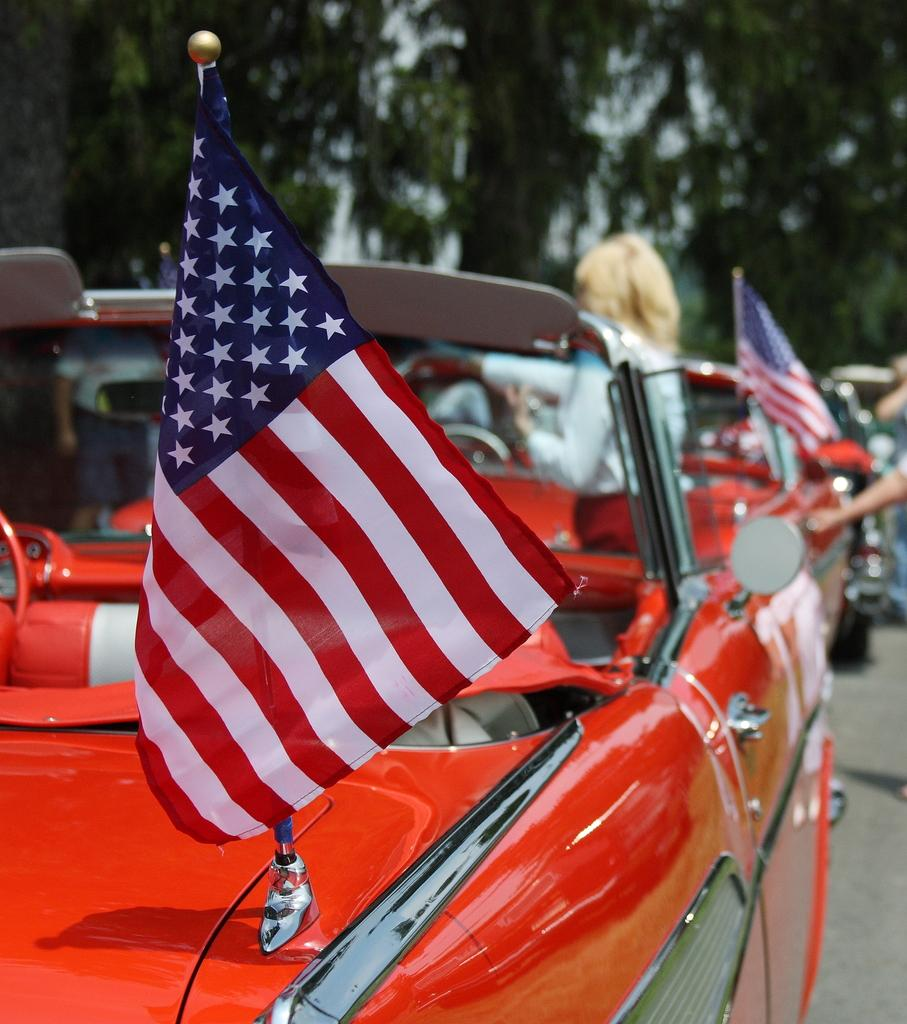What type of vehicle is in the image? There is a red car in the image. Are there any decorations on the car? Yes, there are flags on the car. What can be seen in the background of the image? Trees are visible at the top of the image. How many cherries are hanging from the branches of the trees in the image? There are no cherries visible in the image; only trees can be seen in the background. 